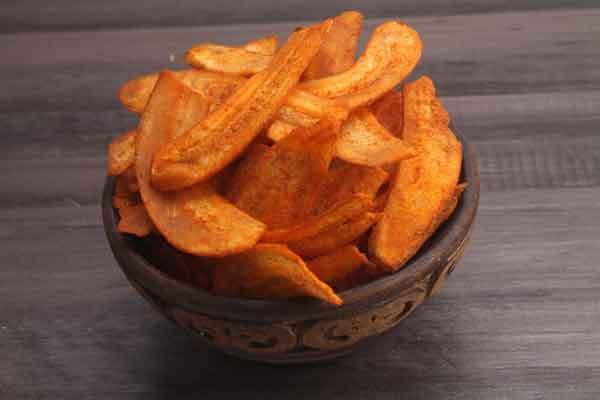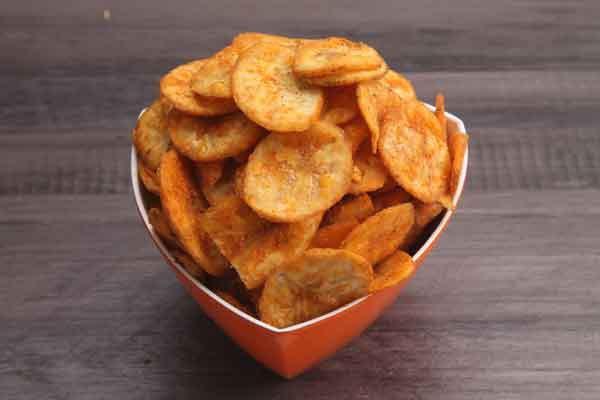The first image is the image on the left, the second image is the image on the right. Given the left and right images, does the statement "The chips in the image on the left are served with a side of red dipping sauce." hold true? Answer yes or no. No. The first image is the image on the left, the second image is the image on the right. Considering the images on both sides, is "The left image shows a fried treat served on a dark plate, with something in a smaller bowl nearby." valid? Answer yes or no. No. 